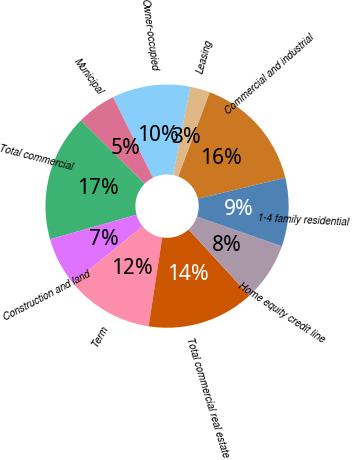Convert chart to OTSL. <chart><loc_0><loc_0><loc_500><loc_500><pie_chart><fcel>Commercial and industrial<fcel>Leasing<fcel>Owner-occupied<fcel>Municipal<fcel>Total commercial<fcel>Construction and land<fcel>Term<fcel>Total commercial real estate<fcel>Home equity credit line<fcel>1-4 family residential<nl><fcel>15.55%<fcel>2.64%<fcel>10.39%<fcel>5.22%<fcel>16.84%<fcel>6.51%<fcel>11.68%<fcel>14.26%<fcel>7.81%<fcel>9.1%<nl></chart> 